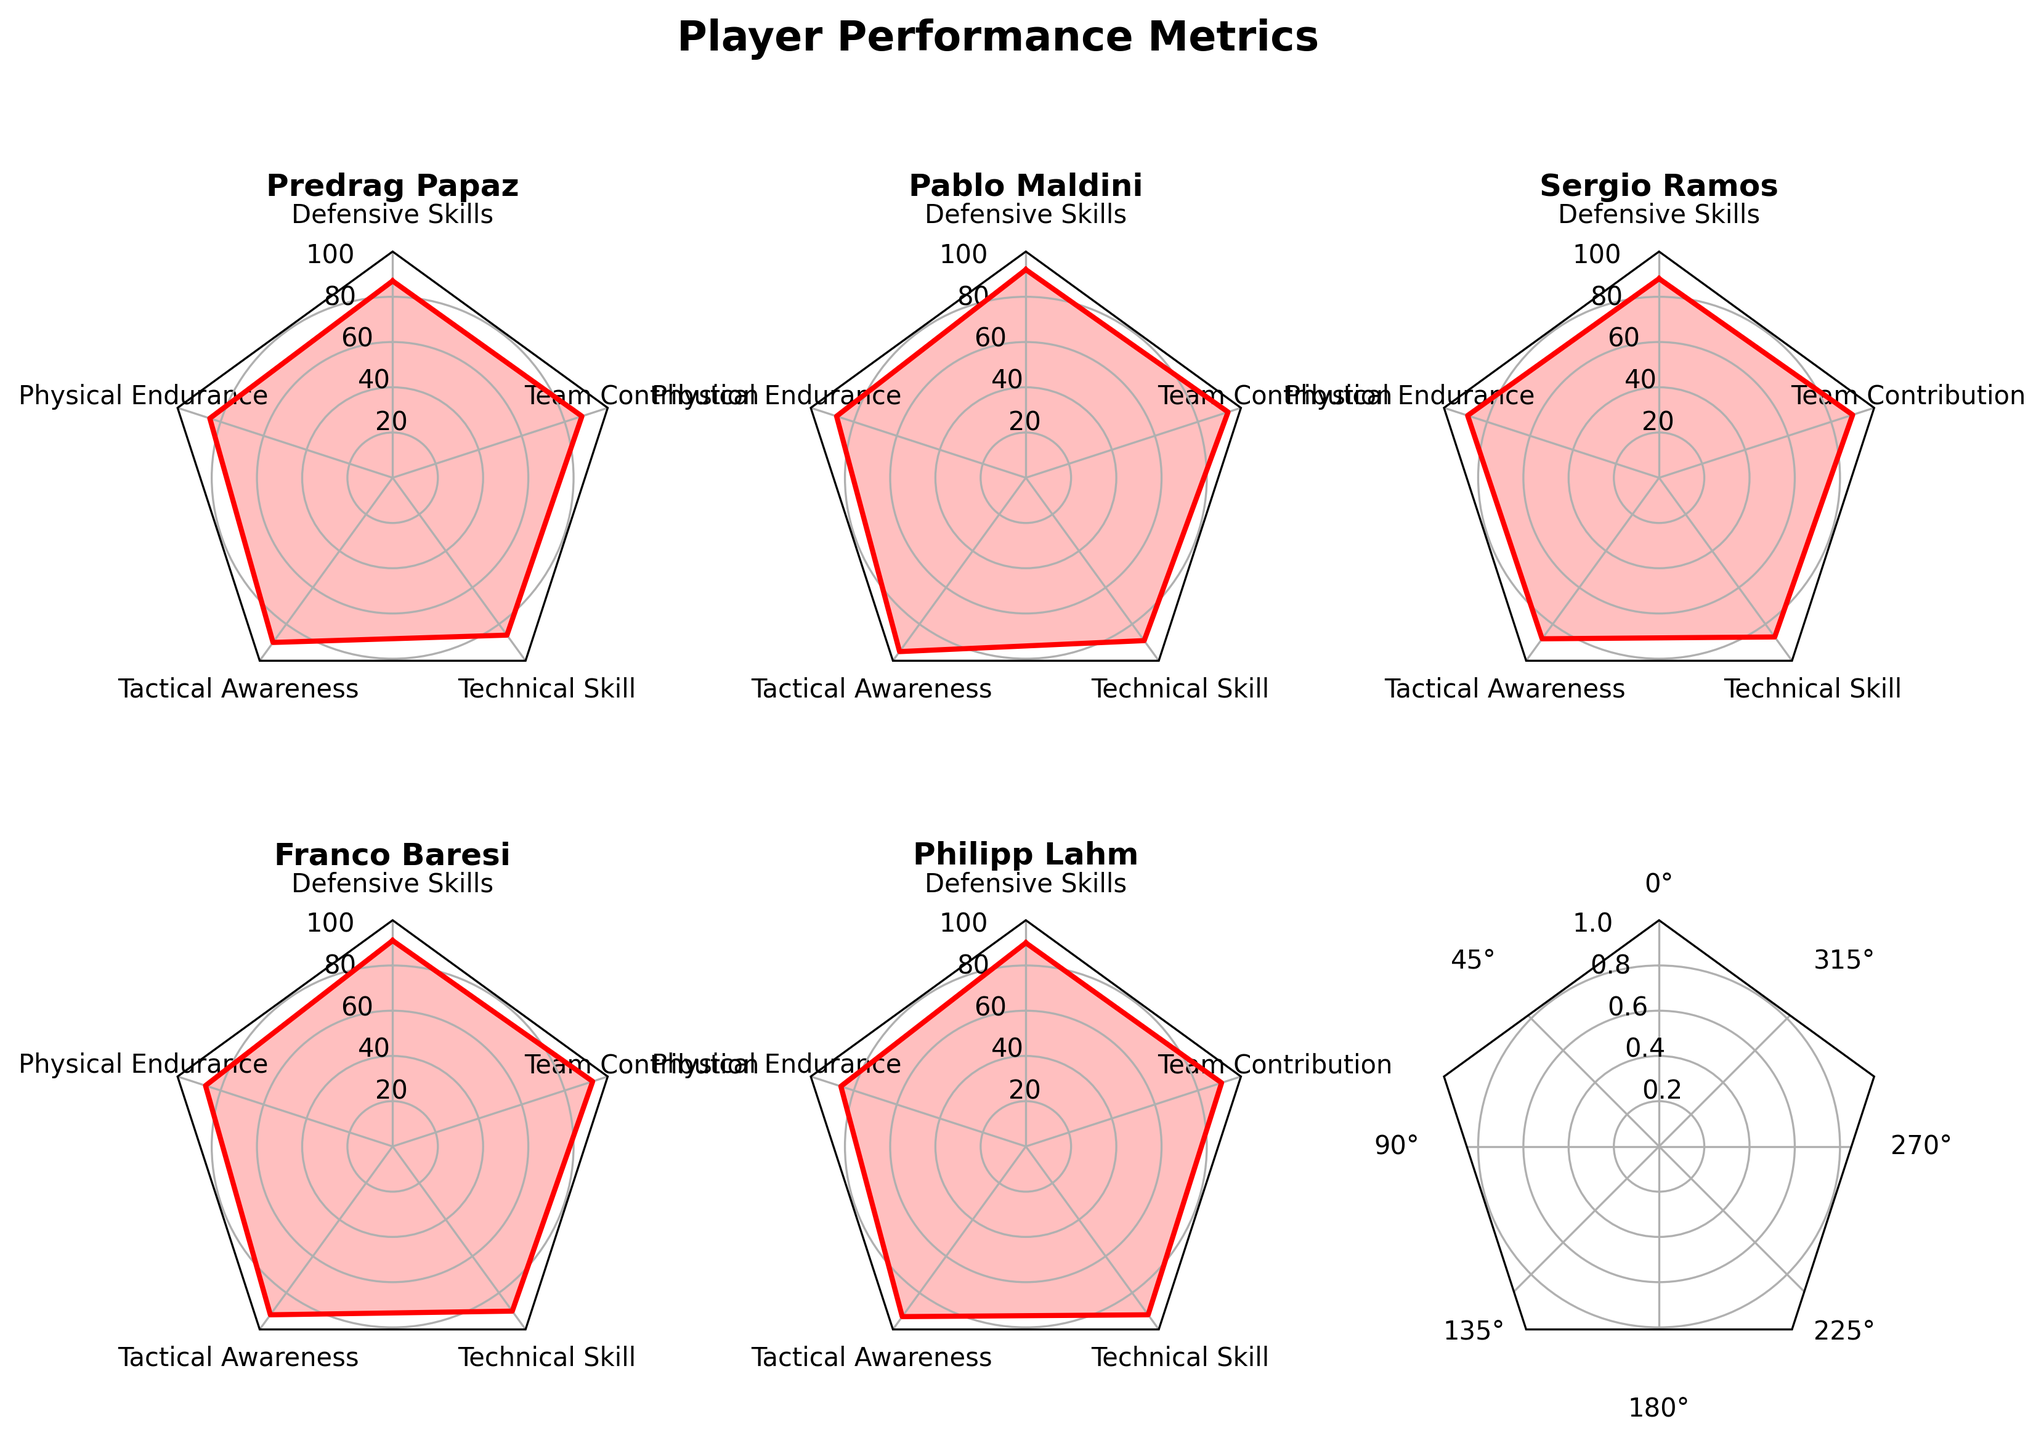Which player has the highest value in Defensive Skills? Look at the Defensive Skills metric and identify the player with the highest score. Pablo Maldini has the highest value of 92.
Answer: Pablo Maldini What is the average Physical Endurance score of all players? Sum the Physical Endurance scores of all players: 85 + 88 + 89 + 87 + 86 = 435. Then divide by the number of players (5). 435 / 5 = 87
Answer: 87 Which player shows the highest Team Contribution? Refer to the Team Contribution metric and see which player has the highest score. Pablo Maldini has a score of 94 which is the highest.
Answer: Pablo Maldini Who has a higher Technical Skill: Predrag Papaz or Franco Baresi? Compare the Technical Skill scores of Predrag Papaz (86) and Franco Baresi (90). Franco Baresi has a higher score.
Answer: Franco Baresi What is the difference in Tactical Awareness between Sergio Ramos and Philipp Lahm? Look at the Tactical Awareness scores for Sergio Ramos (88) and Philipp Lahm (93). The difference is 93 - 88 = 5.
Answer: 5 Which player has the lowest score in any metric and what is that metric? Identify the lowest overall score among all metrics and players. Predrag Papaz has the lowest score in Physical Endurance with 85.
Answer: Predrag Papaz in Physical Endurance How do Sergio Ramos' scores in Defensive Skills and Team Contribution compare? Look at Sergio Ramos' scores in Defensive Skills (88) and Team Contribution (90). His Team Contribution score is 2 points higher than his Defensive Skills.
Answer: Team Contribution is higher Is there any metric where all players score above 85? Check each metric to see if all players have scores above 85. In Team Contribution, the lowest score is 88 (above 85).
Answer: Team Contribution Which player’s performance is most balanced across all metrics? Look for the player whose scores are closest together across all metrics. Philipp Lahm has scores of 90, 86, 93, 92, 91, showing balanced performance.
Answer: Philipp Lahm Which metric shows the greatest variance among players? Calculate the variance for each metric. Physical Endurance: 85, 88, 89, 87, 86 has lowest variance compared to others. Compare variances visually; “Tactical Awareness” shows higher variance due to scores spreading further apart visually.
Answer: Tactical Awareness 